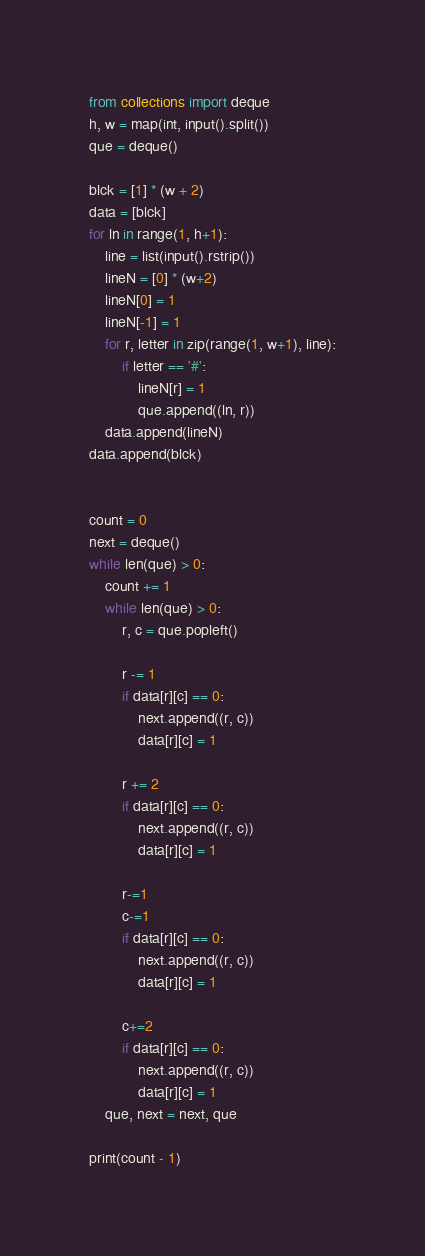Convert code to text. <code><loc_0><loc_0><loc_500><loc_500><_Python_>from collections import deque
h, w = map(int, input().split())
que = deque()

blck = [1] * (w + 2)
data = [blck]
for ln in range(1, h+1):
    line = list(input().rstrip())
    lineN = [0] * (w+2)
    lineN[0] = 1
    lineN[-1] = 1
    for r, letter in zip(range(1, w+1), line):
        if letter == '#':
            lineN[r] = 1
            que.append((ln, r))
    data.append(lineN)
data.append(blck)


count = 0
next = deque()
while len(que) > 0:
    count += 1
    while len(que) > 0:
        r, c = que.popleft()

        r -= 1
        if data[r][c] == 0:
            next.append((r, c))
            data[r][c] = 1

        r += 2
        if data[r][c] == 0:
            next.append((r, c))
            data[r][c] = 1

        r-=1
        c-=1
        if data[r][c] == 0:
            next.append((r, c))
            data[r][c] = 1

        c+=2
        if data[r][c] == 0:
            next.append((r, c))
            data[r][c] = 1
    que, next = next, que

print(count - 1)</code> 